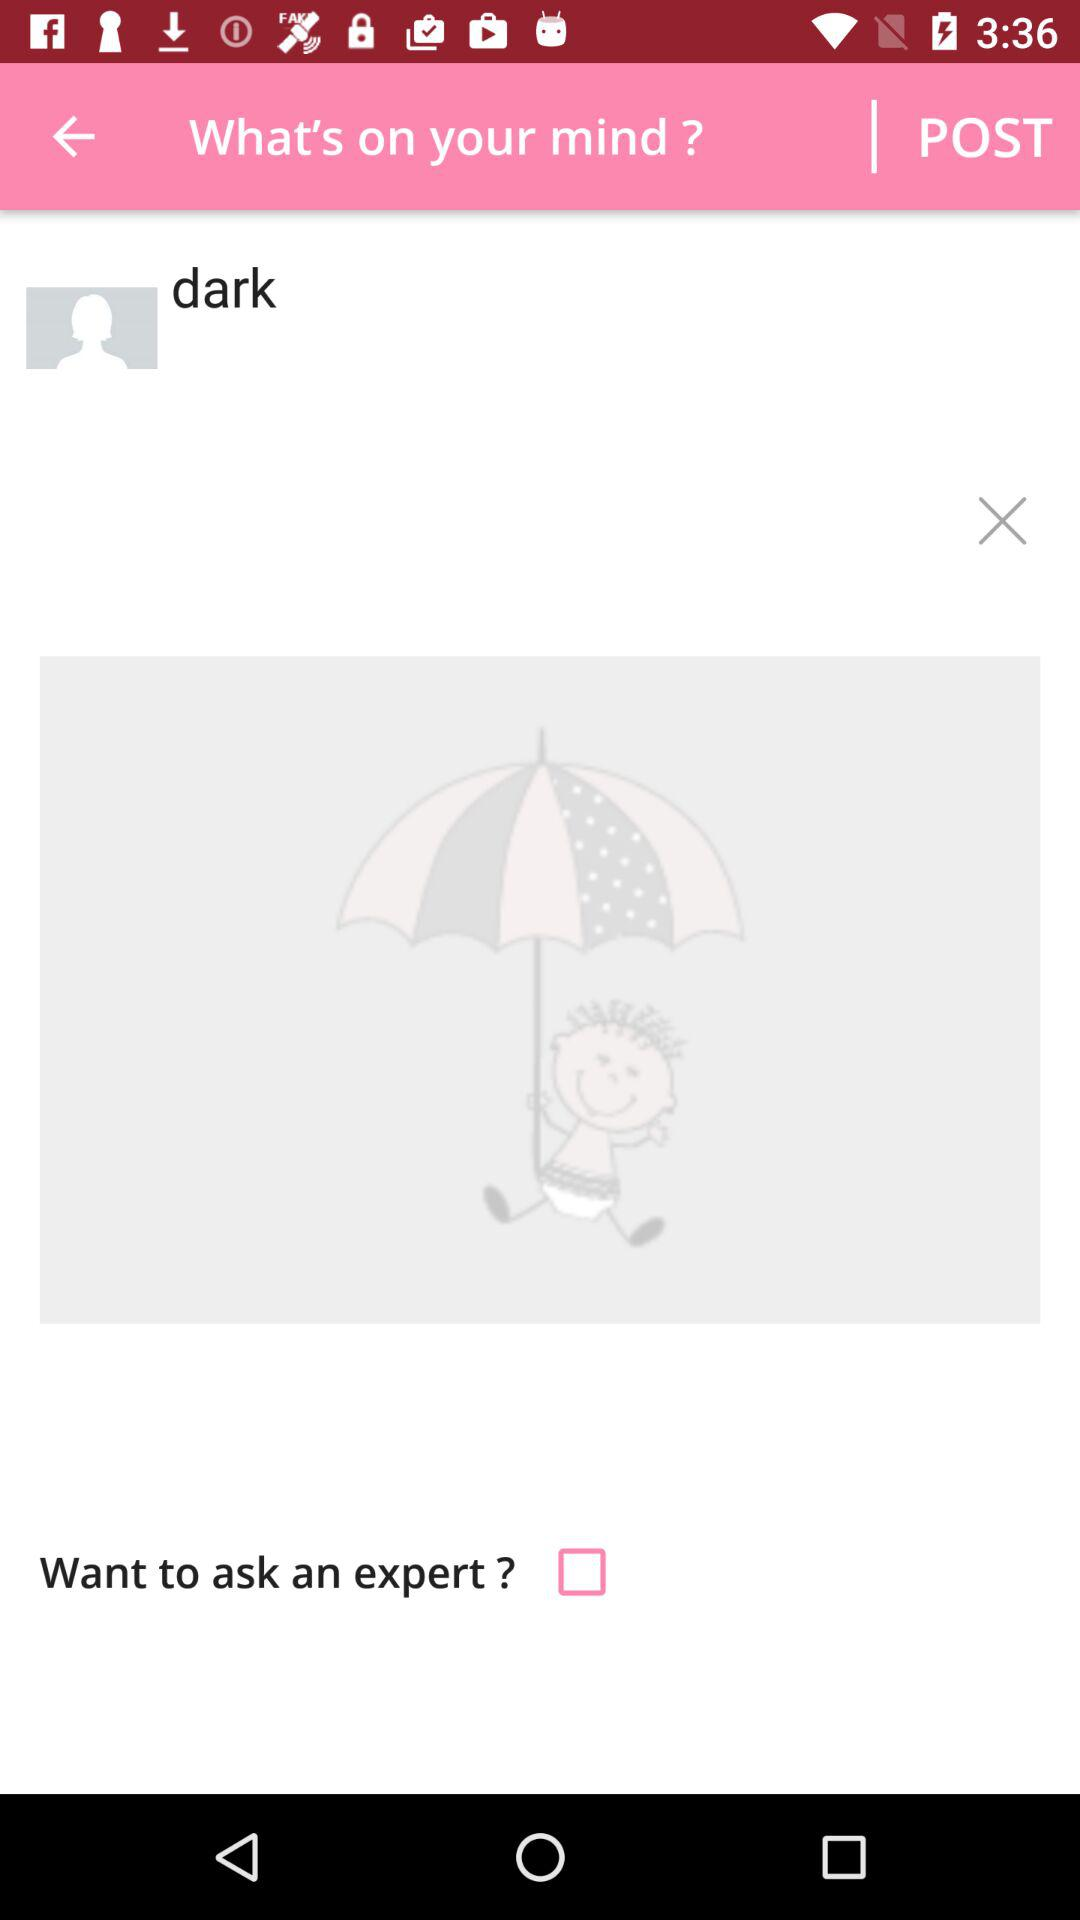What is the name of user?
When the provided information is insufficient, respond with <no answer>. <no answer> 